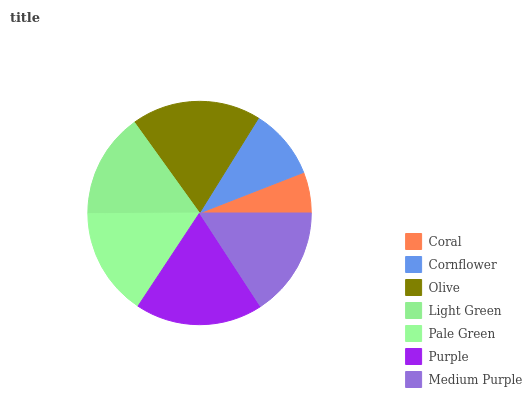Is Coral the minimum?
Answer yes or no. Yes. Is Olive the maximum?
Answer yes or no. Yes. Is Cornflower the minimum?
Answer yes or no. No. Is Cornflower the maximum?
Answer yes or no. No. Is Cornflower greater than Coral?
Answer yes or no. Yes. Is Coral less than Cornflower?
Answer yes or no. Yes. Is Coral greater than Cornflower?
Answer yes or no. No. Is Cornflower less than Coral?
Answer yes or no. No. Is Pale Green the high median?
Answer yes or no. Yes. Is Pale Green the low median?
Answer yes or no. Yes. Is Coral the high median?
Answer yes or no. No. Is Coral the low median?
Answer yes or no. No. 